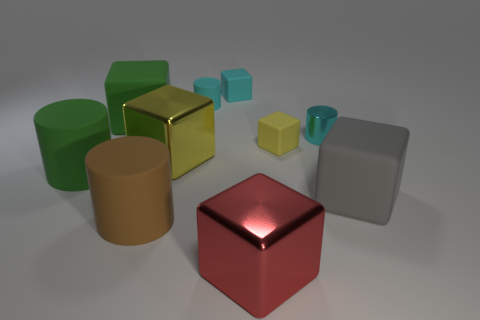Which objects in the image could possibly hold liquid? Considering the shapes and contours, the cyan-colored cup with a rounded opening towards the back of the image looks capable of holding liquid. 